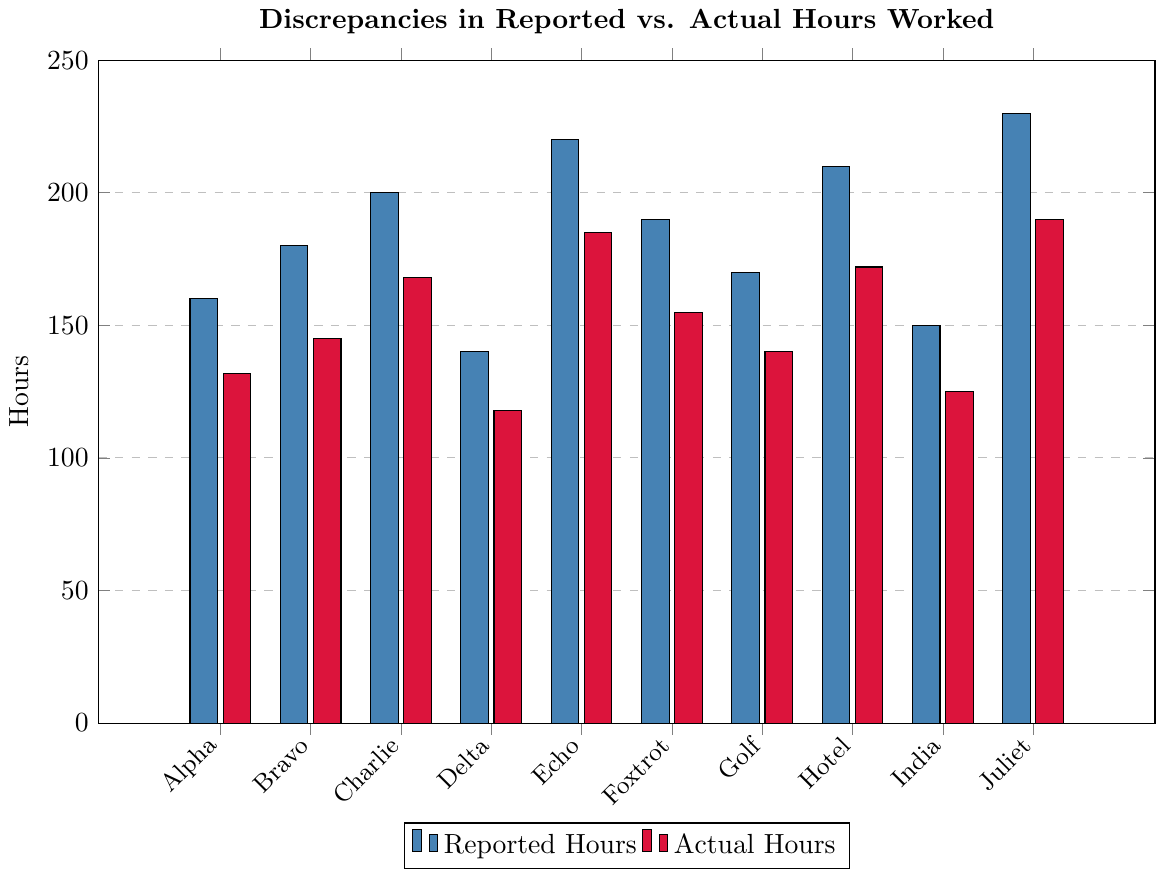Which project has the largest discrepancy between reported hours and actual hours? To determine the largest discrepancy, we need to subtract the actual hours from the reported hours for each project and then compare the differences. Project Juliet: 230 - 190 = 40, Project Alpha: 160 - 132 = 28, etc. Project Juliet has the highest discrepancy of 40 hours.
Answer: Project Juliet What are the total reported hours and total actual hours across all projects? We sum up the reported hours and actual hours from all projects. Reported: 160 + 180 + 200 + 140 + 220 + 190 + 170 + 210 + 150 + 230 = 1850. Actual: 132 + 145 + 168 + 118 + 185 + 155 + 140 + 172 + 125 + 190 = 1530.
Answer: Reported: 1850, Actual: 1530 Which project has the smallest discrepancy between reported hours and actual hours? To find the smallest discrepancy, calculate the difference for each project. Project Golf: 170 - 140 = 30, etc. Project Charlie: 200 - 168 = 32, etc. Project Delta has the smallest difference: 140 - 118 = 22.
Answer: Project Delta How many projects have a discrepancy of more than 40 hours? Compute the discrepancies by subtracting actual from reported hours for each project. Project Juliet: 230 - 190 = 40, Project Echo: 220 - 185 = 35, etc. No discrepancy exceeds 40.
Answer: 0 What is the average discrepancy between reported and actual hours across all projects? First, find the discrepancies for each project. Sum the discrepancies and divide by the number of projects: (28 + 35 + 32 + 22 + 35 + 35 + 30 + 38 + 25 + 40)/10 = 32
Answer: 32 Which two projects have the closest reported hours? Compare the reported hours of all projects in pairs and find the two with the smallest difference. Project Delta (140) and Project India (150) have a difference of only 10 hours.
Answer: Project Delta and Project India What color represents the actual hours in the bar chart? Identify the visual attribute of the bars representing actual hours in the chart. The shorter bars of all pairs are colored red.
Answer: Red Compare the reported hours of Project Bravo and Project Golf. Which one is higher? Compare the heights of the bars for Project Bravo and Project Golf. Project Bravo's reported hours are 180, Project Golf's are 170. So, Project Bravo has higher reported hours.
Answer: Project Bravo What is the difference between the reported and actual hours for Project Alpha? Subtract the actual hours from the reported hours for Project Alpha: 160 - 132 = 28.
Answer: 28 How many projects have reported hours greater than 200? Count the projects with reported hours above 200: Project Echo, Project Hotel, and Project Juliet have reported hours exceeding 200. That is three projects.
Answer: 3 